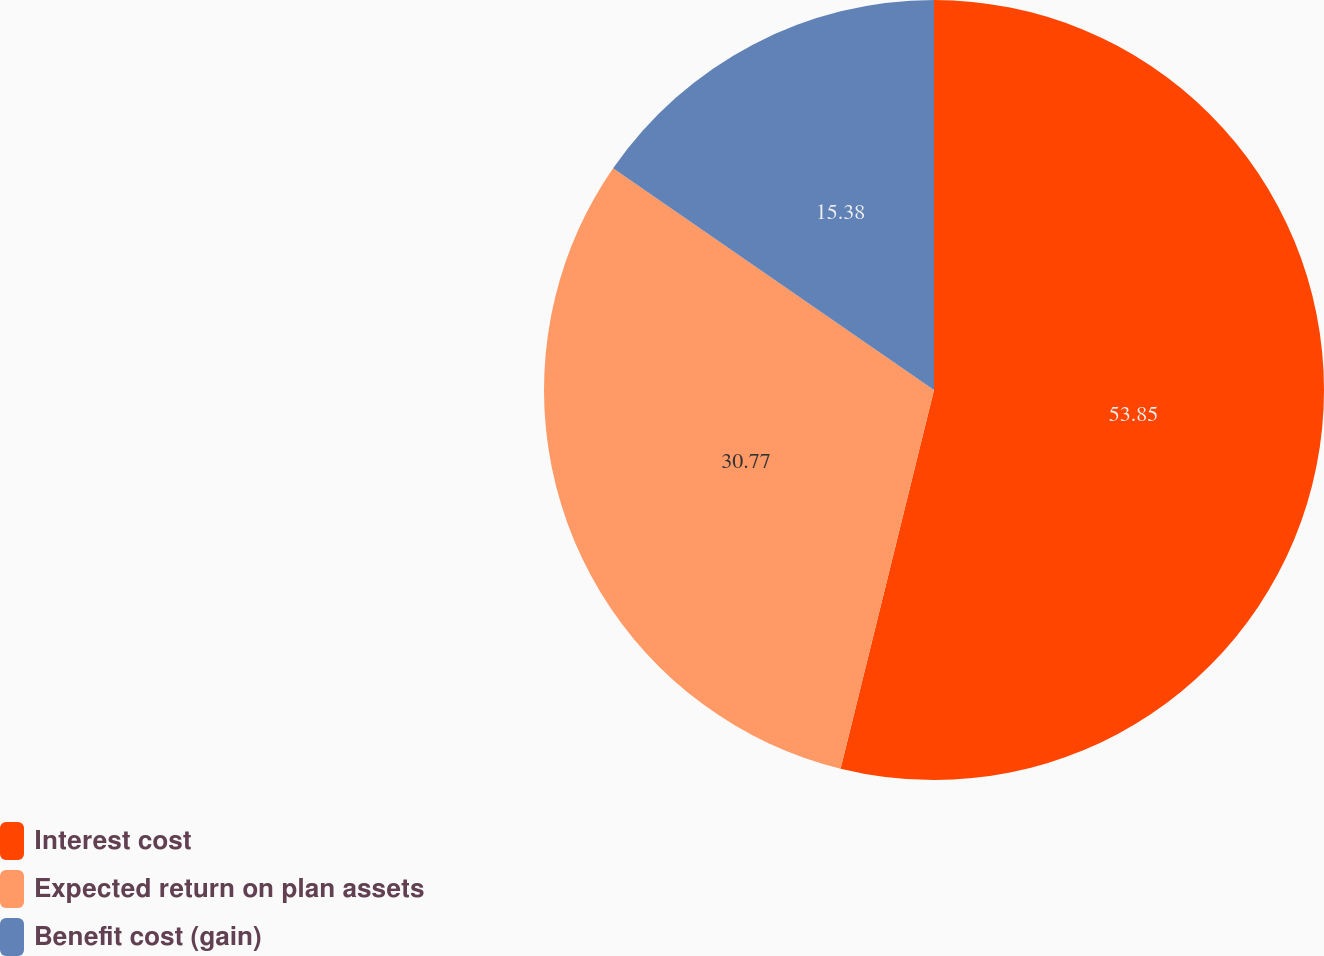<chart> <loc_0><loc_0><loc_500><loc_500><pie_chart><fcel>Interest cost<fcel>Expected return on plan assets<fcel>Benefit cost (gain)<nl><fcel>53.85%<fcel>30.77%<fcel>15.38%<nl></chart> 